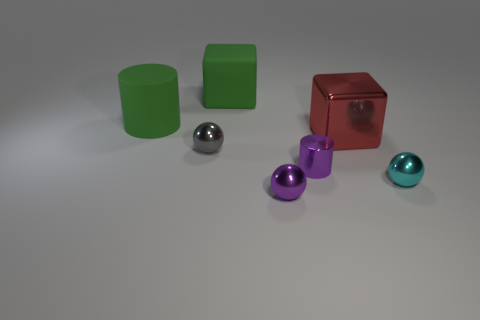There is a big block behind the big metal cube; is it the same color as the large rubber cylinder?
Make the answer very short. Yes. Is there a metal thing that has the same color as the tiny cylinder?
Give a very brief answer. Yes. Do the big matte cylinder and the large rubber cube have the same color?
Provide a short and direct response. Yes. There is a small thing that is the same color as the metal cylinder; what shape is it?
Offer a very short reply. Sphere. The rubber cylinder that is the same size as the red shiny thing is what color?
Keep it short and to the point. Green. What number of objects are either tiny objects to the right of the red cube or big green metal spheres?
Keep it short and to the point. 1. What size is the shiny thing that is both right of the purple metal cylinder and left of the cyan metal object?
Make the answer very short. Large. What is the size of the rubber block that is the same color as the large cylinder?
Your answer should be very brief. Large. What number of other things are there of the same size as the purple cylinder?
Offer a terse response. 3. What color is the cylinder that is to the left of the small gray thing behind the cylinder in front of the big green cylinder?
Your answer should be very brief. Green. 